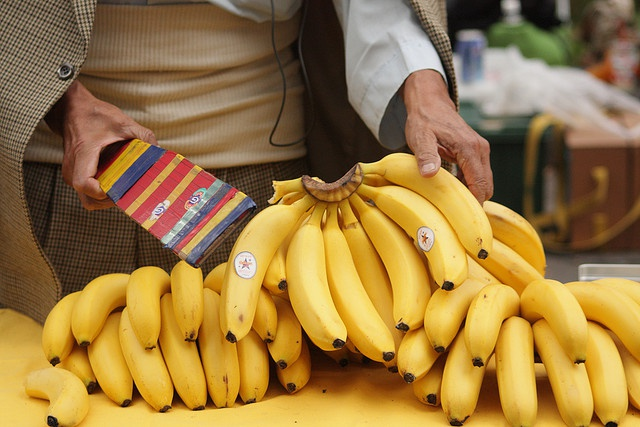Describe the objects in this image and their specific colors. I can see people in darkgreen, black, maroon, and gray tones, banana in darkgreen, gold, orange, and khaki tones, banana in darkgreen, orange, olive, and gold tones, banana in darkgreen, khaki, orange, gold, and olive tones, and banana in darkgreen, orange, gold, and olive tones in this image. 